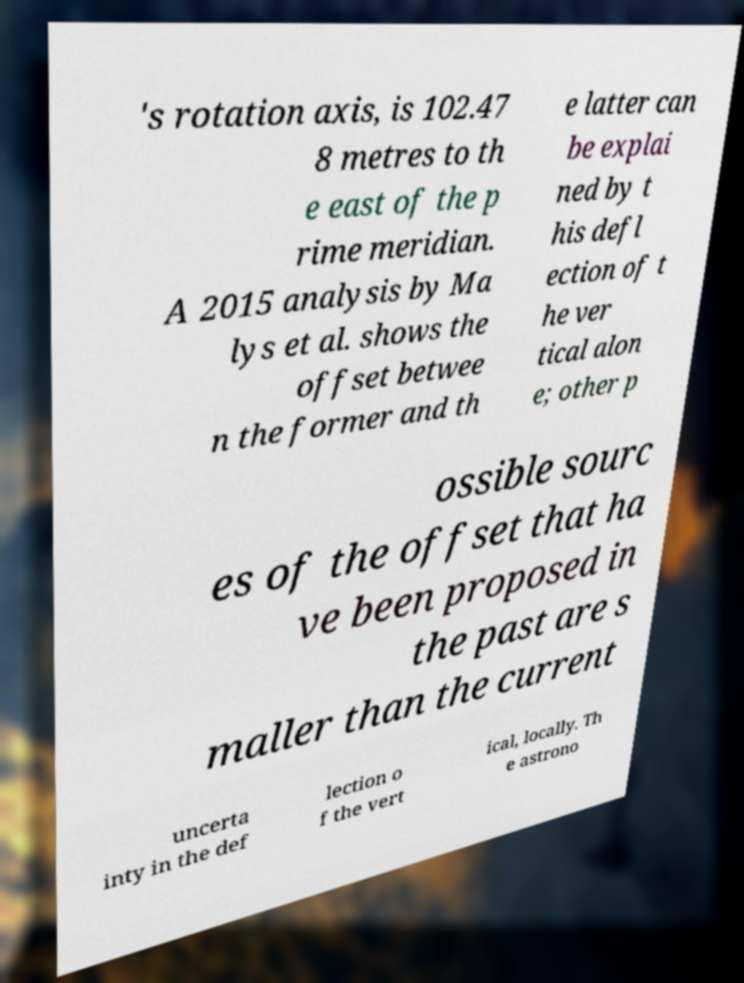Could you assist in decoding the text presented in this image and type it out clearly? 's rotation axis, is 102.47 8 metres to th e east of the p rime meridian. A 2015 analysis by Ma lys et al. shows the offset betwee n the former and th e latter can be explai ned by t his defl ection of t he ver tical alon e; other p ossible sourc es of the offset that ha ve been proposed in the past are s maller than the current uncerta inty in the def lection o f the vert ical, locally. Th e astrono 